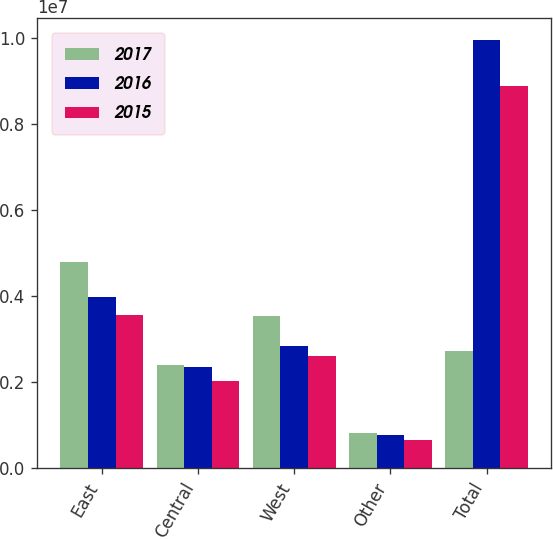Convert chart to OTSL. <chart><loc_0><loc_0><loc_500><loc_500><stacked_bar_chart><ecel><fcel>East<fcel>Central<fcel>West<fcel>Other<fcel>Total<nl><fcel>2017<fcel>4.79574e+06<fcel>2.40956e+06<fcel>3.52994e+06<fcel>823993<fcel>2.72519e+06<nl><fcel>2016<fcel>3.9776e+06<fcel>2.35462e+06<fcel>2.83299e+06<fcel>788721<fcel>9.95394e+06<nl><fcel>2015<fcel>3.5705e+06<fcel>2.03734e+06<fcel>2.61739e+06<fcel>663247<fcel>8.88848e+06<nl></chart> 